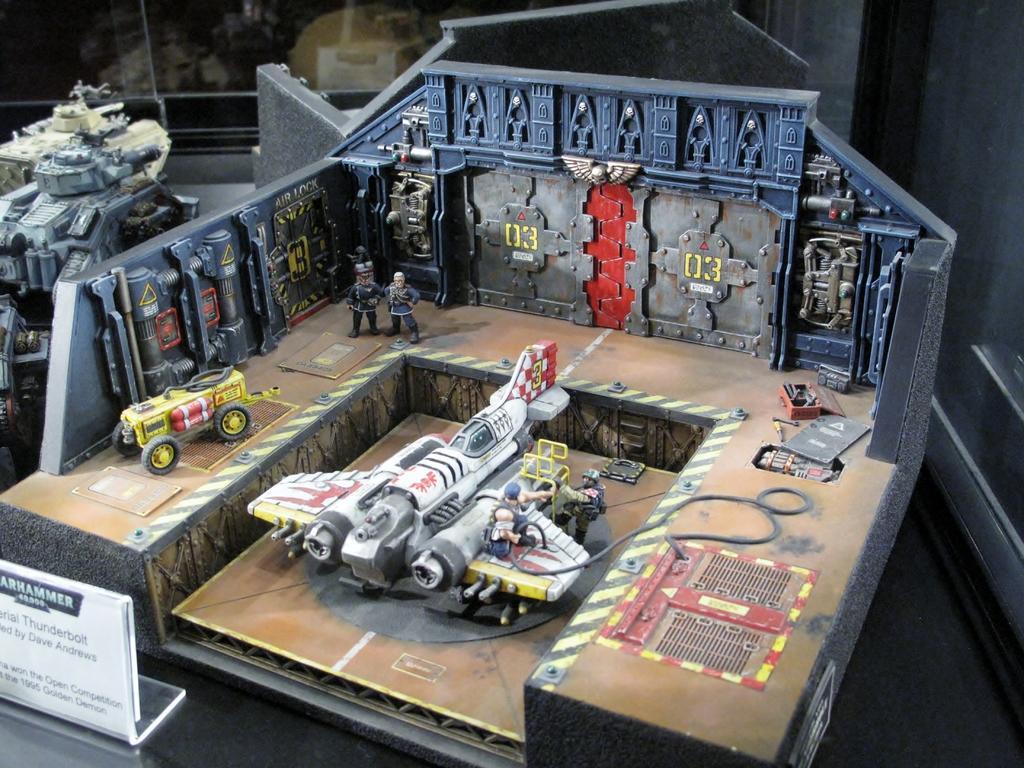In one or two sentences, can you explain what this image depicts? In this picture we can see toys and this is board. 